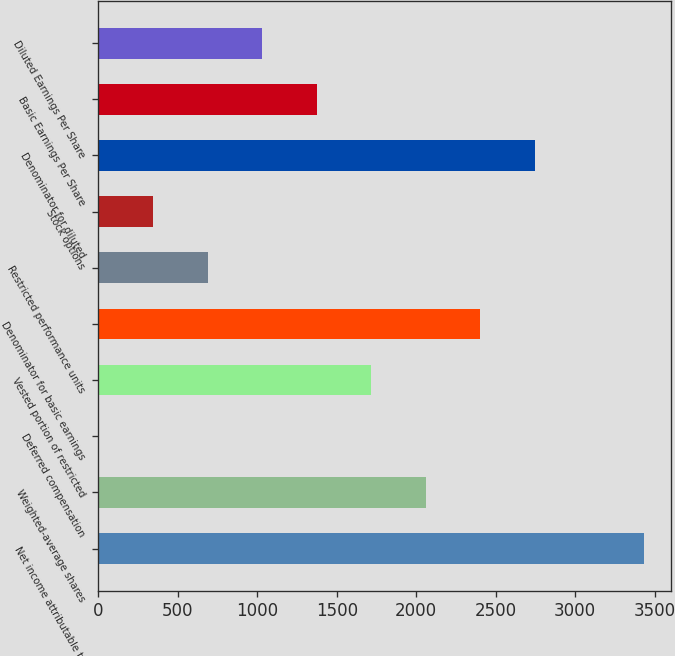<chart> <loc_0><loc_0><loc_500><loc_500><bar_chart><fcel>Net income attributable to<fcel>Weighted-average shares<fcel>Deferred compensation<fcel>Vested portion of restricted<fcel>Denominator for basic earnings<fcel>Restricted performance units<fcel>Stock options<fcel>Denominator for diluted<fcel>Basic Earnings Per Share<fcel>Diluted Earnings Per Share<nl><fcel>3431<fcel>2059<fcel>1<fcel>1716<fcel>2402<fcel>687<fcel>344<fcel>2745<fcel>1373<fcel>1030<nl></chart> 